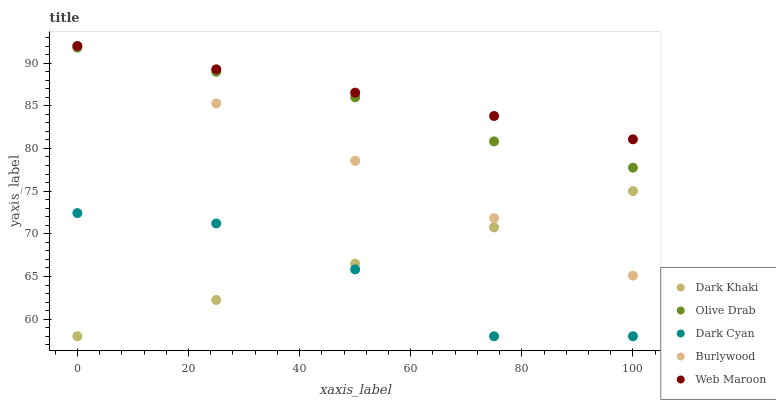Does Dark Cyan have the minimum area under the curve?
Answer yes or no. Yes. Does Web Maroon have the maximum area under the curve?
Answer yes or no. Yes. Does Web Maroon have the minimum area under the curve?
Answer yes or no. No. Does Dark Cyan have the maximum area under the curve?
Answer yes or no. No. Is Dark Khaki the smoothest?
Answer yes or no. Yes. Is Dark Cyan the roughest?
Answer yes or no. Yes. Is Dark Cyan the smoothest?
Answer yes or no. No. Is Web Maroon the roughest?
Answer yes or no. No. Does Dark Khaki have the lowest value?
Answer yes or no. Yes. Does Web Maroon have the lowest value?
Answer yes or no. No. Does Burlywood have the highest value?
Answer yes or no. Yes. Does Dark Cyan have the highest value?
Answer yes or no. No. Is Dark Cyan less than Web Maroon?
Answer yes or no. Yes. Is Olive Drab greater than Dark Cyan?
Answer yes or no. Yes. Does Olive Drab intersect Burlywood?
Answer yes or no. Yes. Is Olive Drab less than Burlywood?
Answer yes or no. No. Is Olive Drab greater than Burlywood?
Answer yes or no. No. Does Dark Cyan intersect Web Maroon?
Answer yes or no. No. 